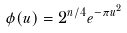Convert formula to latex. <formula><loc_0><loc_0><loc_500><loc_500>\phi ( u ) = 2 ^ { n / 4 } e ^ { - \pi u ^ { 2 } }</formula> 